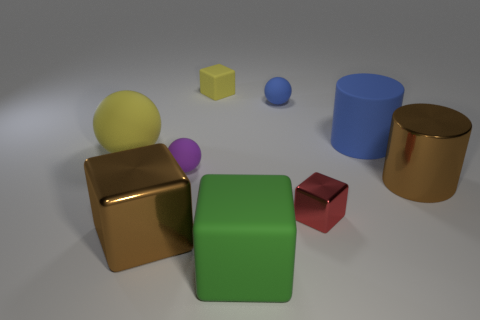There is a large rubber object that is right of the large sphere and left of the small metal cube; what is its shape?
Offer a very short reply. Cube. What number of other things are the same color as the metallic cylinder?
Your response must be concise. 1. How many things are either large brown metallic things that are left of the green cube or red matte cylinders?
Your response must be concise. 1. There is a big ball; is its color the same as the big shiny object on the left side of the purple ball?
Offer a terse response. No. Is there anything else that has the same size as the yellow matte ball?
Make the answer very short. Yes. What size is the blue thing that is right of the red shiny object in front of the tiny blue matte sphere?
Give a very brief answer. Large. How many things are small metal blocks or tiny blocks behind the large yellow sphere?
Keep it short and to the point. 2. Do the large shiny thing that is behind the red metal block and the large green rubber thing have the same shape?
Make the answer very short. No. There is a metal cube on the left side of the small yellow matte object that is behind the big brown metal cylinder; how many yellow balls are right of it?
Offer a terse response. 0. Is there any other thing that has the same shape as the small purple matte object?
Give a very brief answer. Yes. 